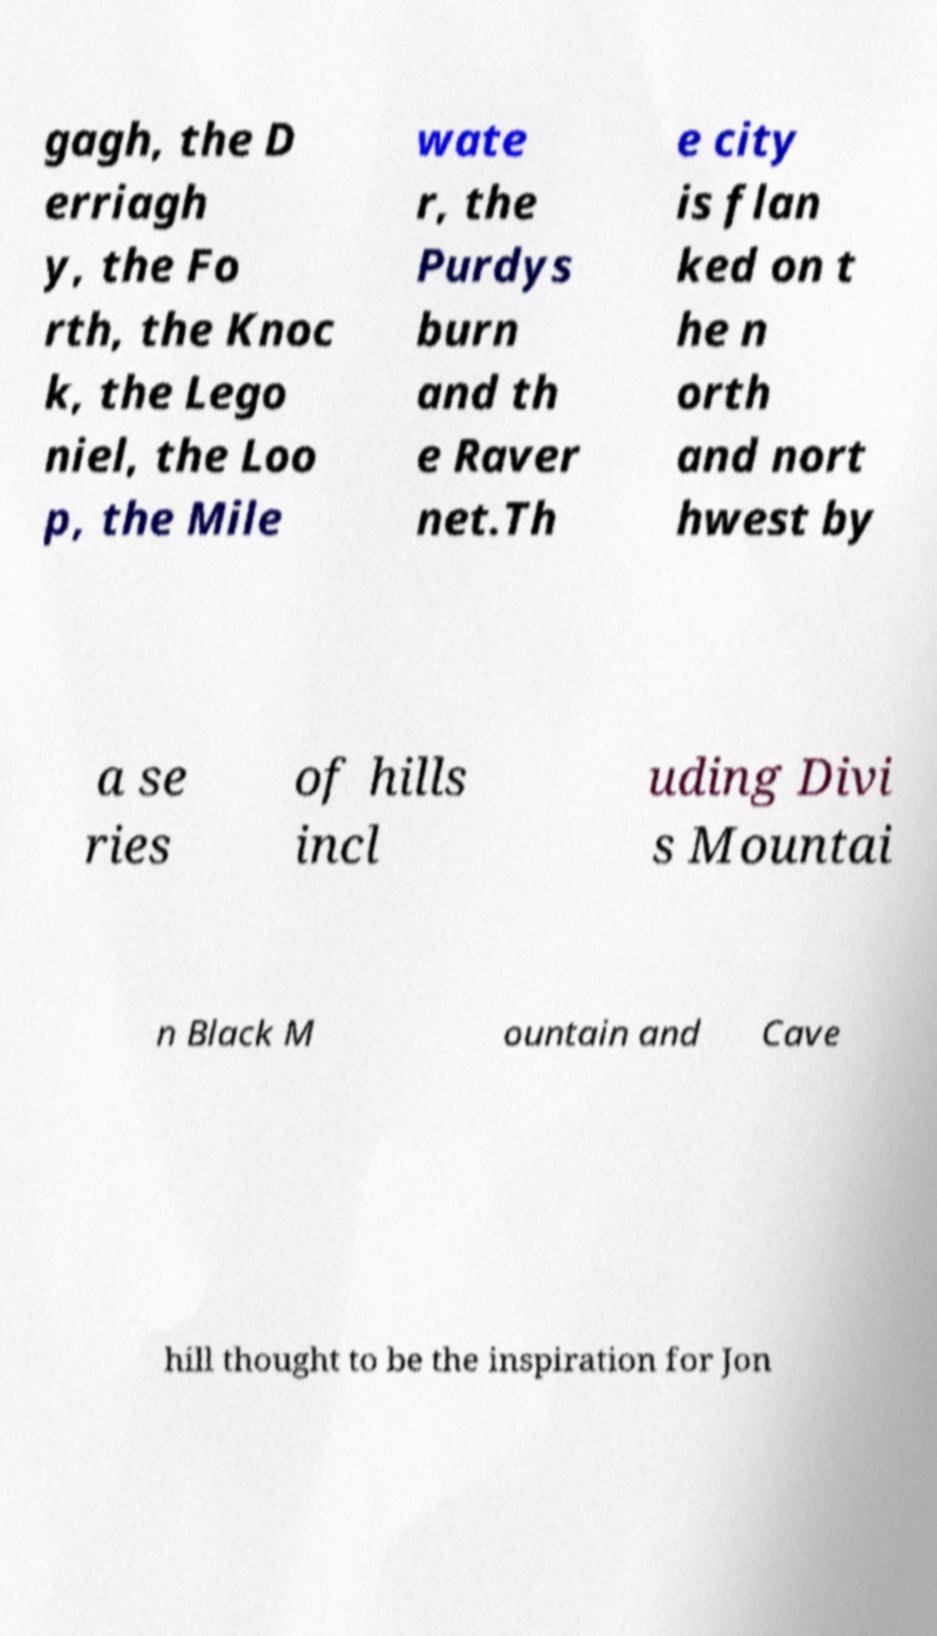For documentation purposes, I need the text within this image transcribed. Could you provide that? gagh, the D erriagh y, the Fo rth, the Knoc k, the Lego niel, the Loo p, the Mile wate r, the Purdys burn and th e Raver net.Th e city is flan ked on t he n orth and nort hwest by a se ries of hills incl uding Divi s Mountai n Black M ountain and Cave hill thought to be the inspiration for Jon 